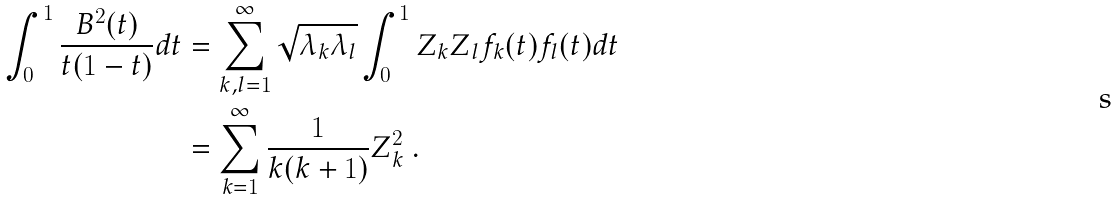<formula> <loc_0><loc_0><loc_500><loc_500>\int _ { 0 } ^ { 1 } \frac { B ^ { 2 } ( t ) } { t ( 1 - t ) } d t & = \sum _ { k , l = 1 } ^ { \infty } \sqrt { \lambda _ { k } \lambda _ { l } } \int _ { 0 } ^ { 1 } Z _ { k } Z _ { l } f _ { k } ( t ) f _ { l } ( t ) d t \\ & = \sum _ { k = 1 } ^ { \infty } \frac { 1 } { k ( k + 1 ) } Z _ { k } ^ { 2 } \ .</formula> 